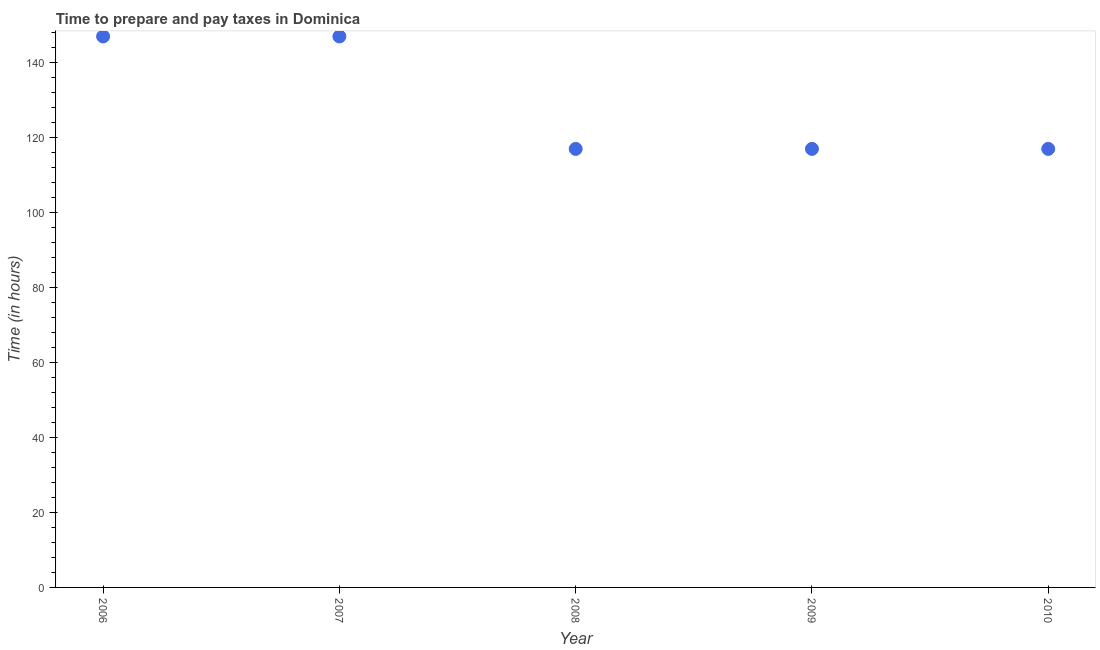What is the time to prepare and pay taxes in 2007?
Your answer should be very brief. 147. Across all years, what is the maximum time to prepare and pay taxes?
Give a very brief answer. 147. Across all years, what is the minimum time to prepare and pay taxes?
Ensure brevity in your answer.  117. What is the sum of the time to prepare and pay taxes?
Keep it short and to the point. 645. What is the average time to prepare and pay taxes per year?
Offer a terse response. 129. What is the median time to prepare and pay taxes?
Provide a succinct answer. 117. In how many years, is the time to prepare and pay taxes greater than 124 hours?
Make the answer very short. 2. What is the ratio of the time to prepare and pay taxes in 2006 to that in 2010?
Keep it short and to the point. 1.26. What is the difference between the highest and the second highest time to prepare and pay taxes?
Offer a very short reply. 0. Is the sum of the time to prepare and pay taxes in 2008 and 2010 greater than the maximum time to prepare and pay taxes across all years?
Provide a succinct answer. Yes. What is the difference between the highest and the lowest time to prepare and pay taxes?
Offer a terse response. 30. Does the time to prepare and pay taxes monotonically increase over the years?
Your response must be concise. No. How many years are there in the graph?
Offer a very short reply. 5. What is the difference between two consecutive major ticks on the Y-axis?
Your response must be concise. 20. What is the title of the graph?
Ensure brevity in your answer.  Time to prepare and pay taxes in Dominica. What is the label or title of the Y-axis?
Offer a terse response. Time (in hours). What is the Time (in hours) in 2006?
Your answer should be compact. 147. What is the Time (in hours) in 2007?
Give a very brief answer. 147. What is the Time (in hours) in 2008?
Provide a short and direct response. 117. What is the Time (in hours) in 2009?
Ensure brevity in your answer.  117. What is the Time (in hours) in 2010?
Make the answer very short. 117. What is the difference between the Time (in hours) in 2006 and 2007?
Provide a succinct answer. 0. What is the difference between the Time (in hours) in 2006 and 2009?
Your answer should be compact. 30. What is the difference between the Time (in hours) in 2007 and 2010?
Your response must be concise. 30. What is the ratio of the Time (in hours) in 2006 to that in 2008?
Your answer should be very brief. 1.26. What is the ratio of the Time (in hours) in 2006 to that in 2009?
Your answer should be compact. 1.26. What is the ratio of the Time (in hours) in 2006 to that in 2010?
Offer a terse response. 1.26. What is the ratio of the Time (in hours) in 2007 to that in 2008?
Give a very brief answer. 1.26. What is the ratio of the Time (in hours) in 2007 to that in 2009?
Provide a succinct answer. 1.26. What is the ratio of the Time (in hours) in 2007 to that in 2010?
Your answer should be compact. 1.26. What is the ratio of the Time (in hours) in 2008 to that in 2009?
Make the answer very short. 1. 